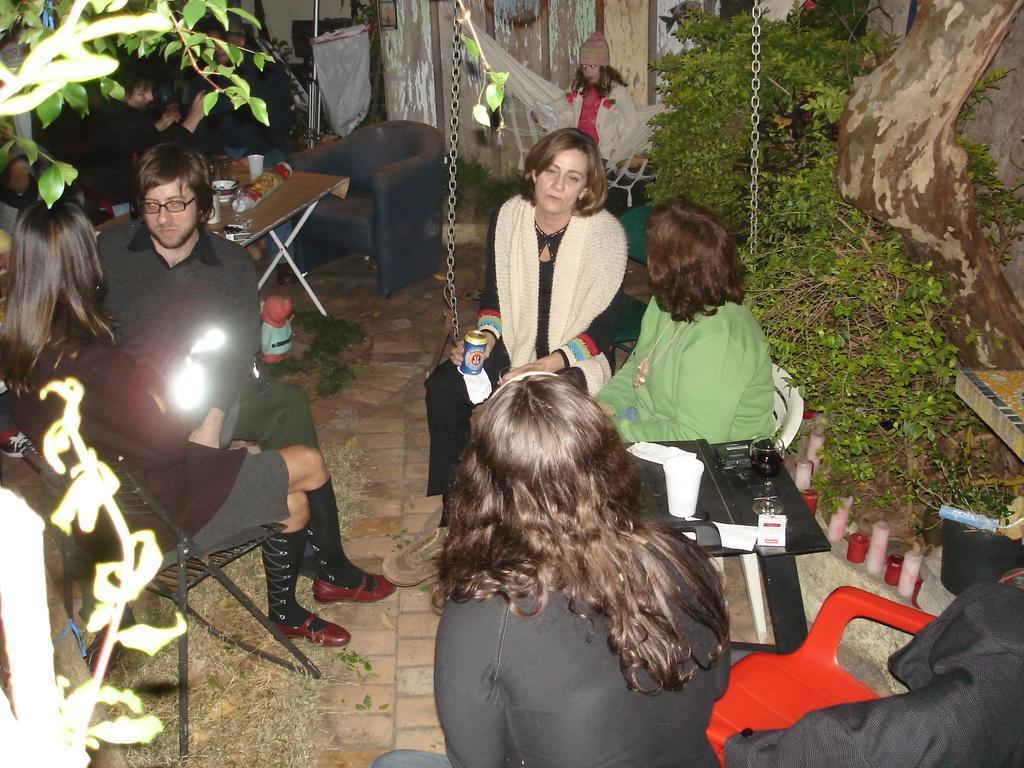Describe this image in one or two sentences. In this image I can see few people are sitting on the chair. We can see glass,cup,paper and some objects on the table. Back Side I can see person is sitting on the swing. We can see trees and wooden wall. 